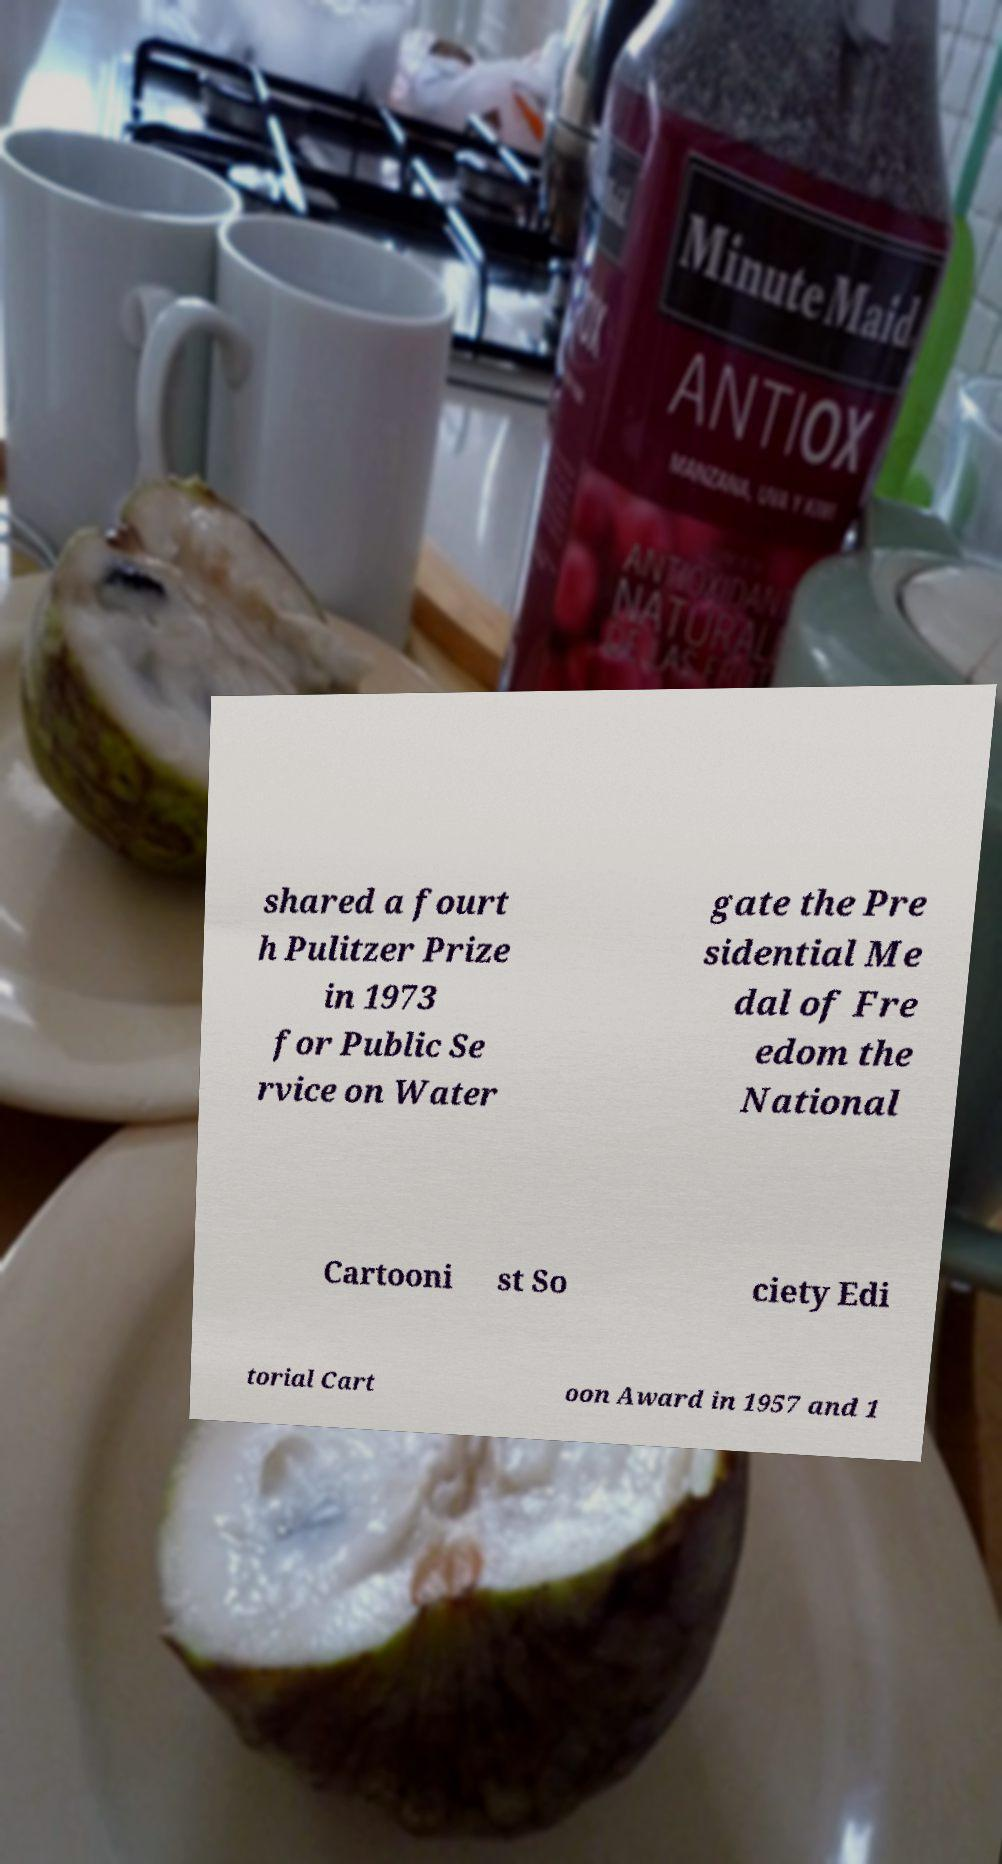Can you read and provide the text displayed in the image?This photo seems to have some interesting text. Can you extract and type it out for me? shared a fourt h Pulitzer Prize in 1973 for Public Se rvice on Water gate the Pre sidential Me dal of Fre edom the National Cartooni st So ciety Edi torial Cart oon Award in 1957 and 1 